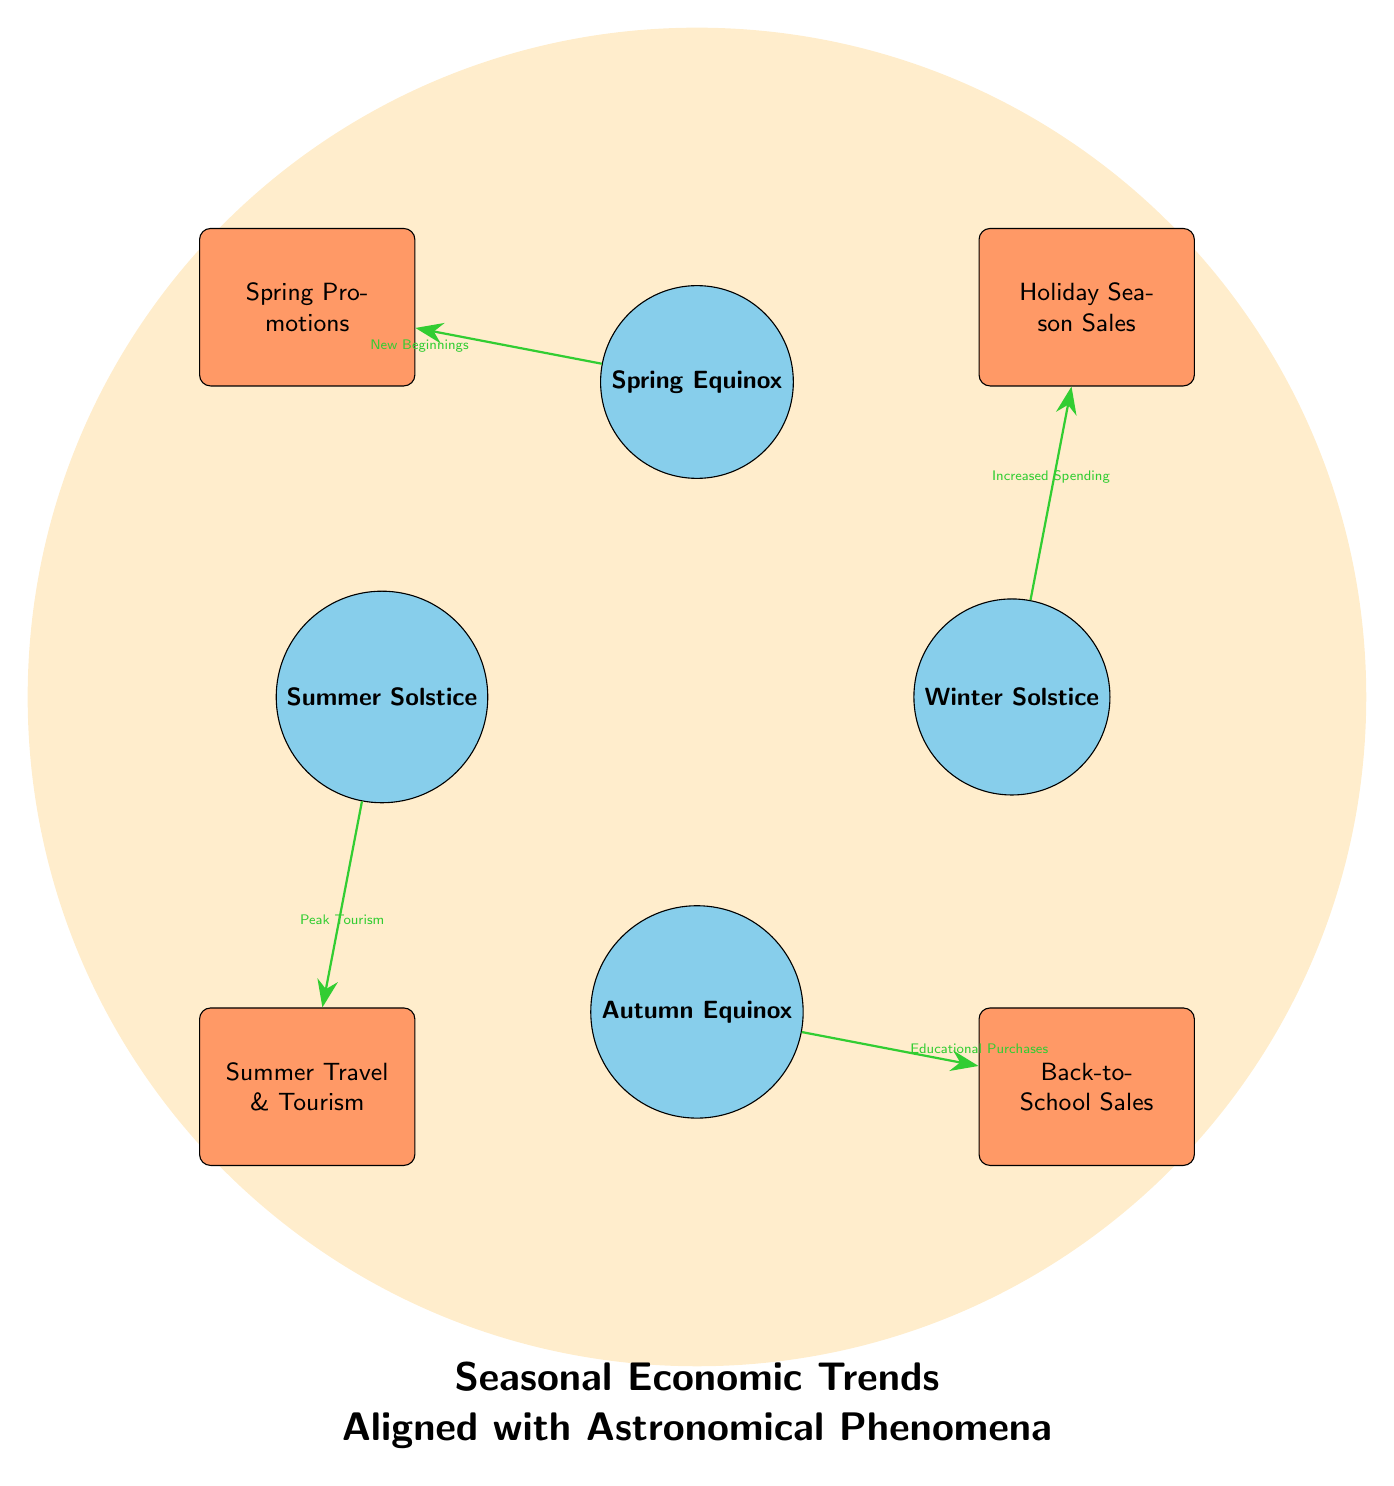What celestial event corresponds to increased spending? The diagram shows an arrow from the Winter Solstice to Holiday Season Sales, labeled "Increased Spending." This indicates that the Winter Solstice is associated with increased consumer spending during the holiday season.
Answer: Winter Solstice What economic trend is related to the Summer Solstice? The diagram connects the Summer Solstice to Summer Travel & Tourism with an arrow, indicating a relationship. The label "Peak Tourism" further confirms that this economic trend is directly related to the Summer Solstice.
Answer: Summer Travel & Tourism How many economic nodes are there? Upon reviewing the diagram, there are four economic nodes displayed: Holiday Season Sales, Spring Promotions, Summer Travel & Tourism, and Back-to-School Sales. Counting these provides the total number.
Answer: Four What is the relationship between Spring Equinox and its economic trend? The Spring Equinox is connected to Spring Promotions, with the arrow indicating the relationship. The label "New Beginnings" suggests that the Spring Equinox influences promotional activities aimed at initiating new sales.
Answer: New Beginnings Which economic activity is aligned with the Autumn Equinox? The diagram shows an arrow leading from the Autumn Equinox to Back-to-School Sales. This indicates that this economic activity is directly tied to the seasonal event of the Autumn Equinox.
Answer: Back-to-School Sales How is the circular topology of the diagram used? The circular arrangement of nodes allows for easy visualization of relationships between seasonal astronomical events and corresponding economic activities. It creates a holistic view of how seasons influence consumer behavior.
Answer: Circular arrangement Which season is associated with peak tourism according to the diagram? The Summer Solstice node connects to the Summer Travel & Tourism economic trend, which is labeled with "Peak Tourism," indicating that this season is known for high levels of tourism-related economic activity.
Answer: Summer Solstice What color represents astronomical events in the diagram? The nodes representing astronomical events are shown in the color sky blue according to the diagram's node style definitions. This visual distinction helps identify them as separate from the economic trends.
Answer: Sky blue What direction does the arrow point from the Winter Solstice? The arrow points from the Winter Solstice (at position 0 degrees) towards Holiday Season Sales, showing the influence of the solstice on economic activities. The arrow moves in a clockwise direction to indicate this connection.
Answer: Clockwise 